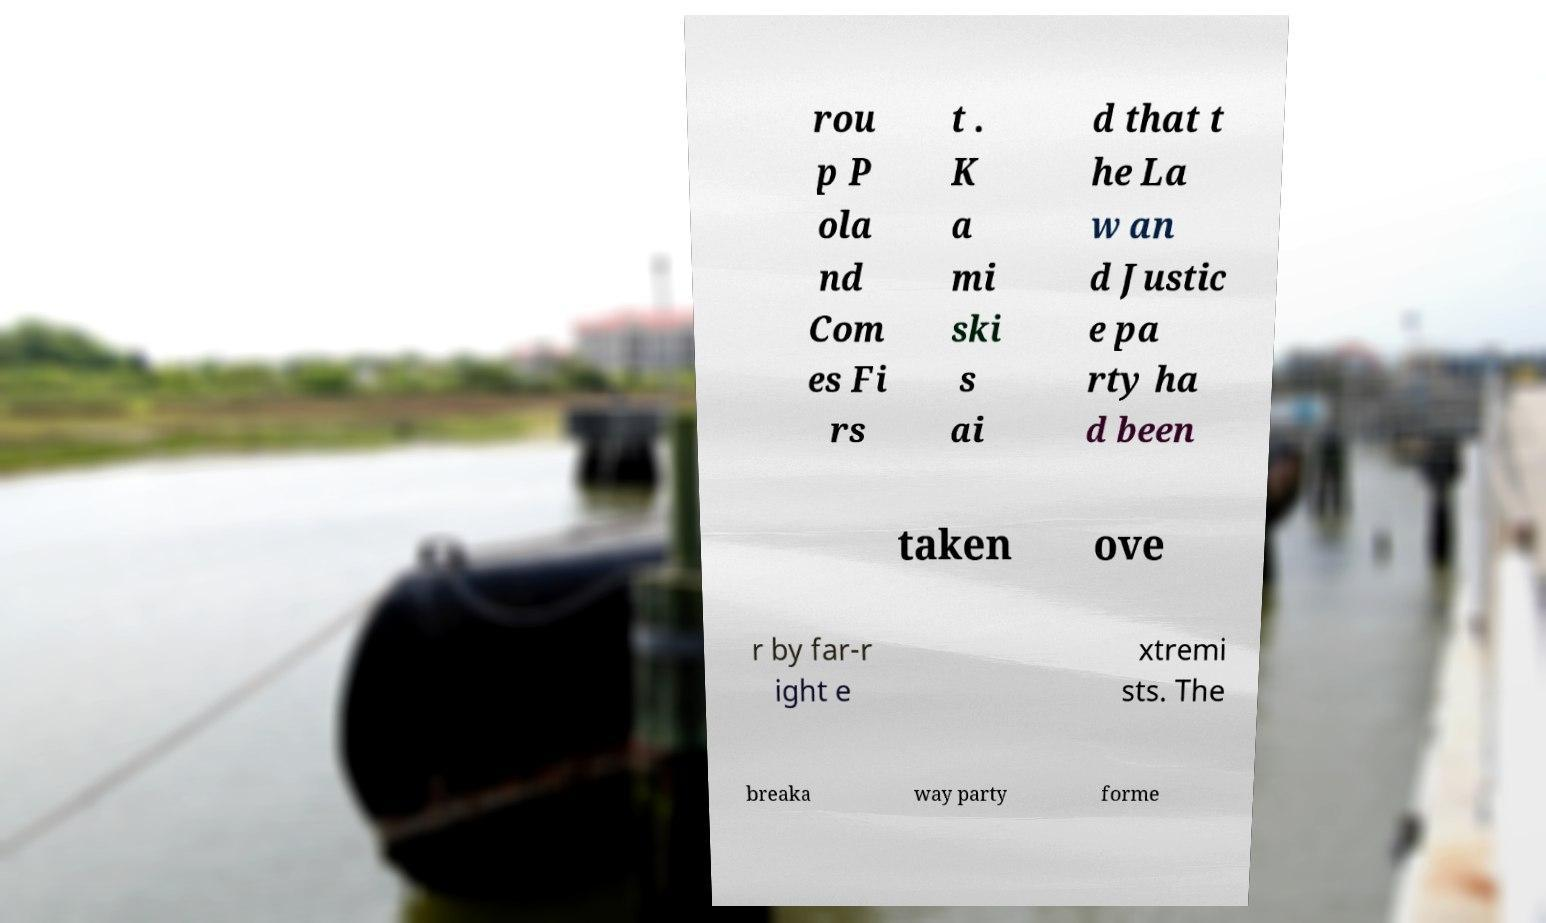I need the written content from this picture converted into text. Can you do that? rou p P ola nd Com es Fi rs t . K a mi ski s ai d that t he La w an d Justic e pa rty ha d been taken ove r by far-r ight e xtremi sts. The breaka way party forme 